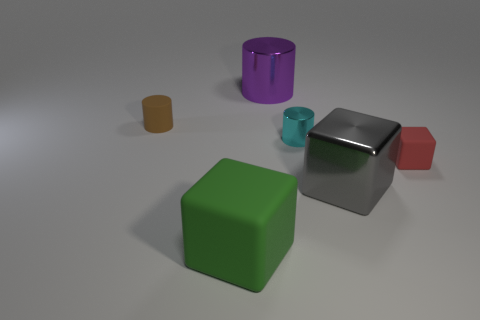Add 1 tiny cyan rubber cubes. How many objects exist? 7 Add 6 small red cubes. How many small red cubes exist? 7 Subtract 0 green cylinders. How many objects are left? 6 Subtract all gray shiny blocks. Subtract all large metal cubes. How many objects are left? 4 Add 4 large matte cubes. How many large matte cubes are left? 5 